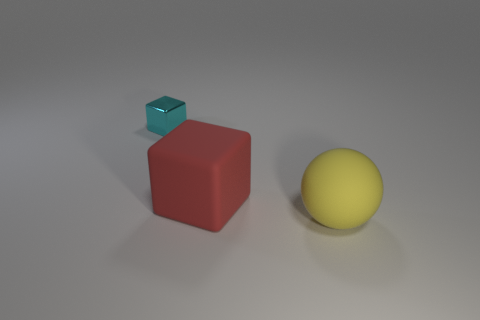Is there anything else that has the same material as the tiny object?
Make the answer very short. No. Is there anything else that has the same shape as the tiny shiny object?
Offer a terse response. Yes. Are there an equal number of large spheres to the left of the red rubber object and big yellow things left of the yellow object?
Your answer should be compact. Yes. How many cylinders are big yellow objects or rubber things?
Keep it short and to the point. 0. What number of other things are the same material as the large sphere?
Give a very brief answer. 1. There is a thing behind the red cube; what is its shape?
Your answer should be very brief. Cube. The block that is to the left of the block to the right of the shiny block is made of what material?
Your response must be concise. Metal. Are there more yellow spheres in front of the large yellow matte ball than large cyan metallic spheres?
Ensure brevity in your answer.  No. The red thing that is the same size as the yellow matte sphere is what shape?
Make the answer very short. Cube. How many yellow rubber spheres are to the left of the cube left of the large thing that is behind the yellow ball?
Offer a very short reply. 0. 